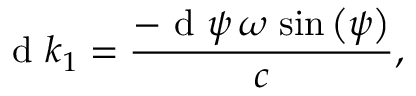Convert formula to latex. <formula><loc_0><loc_0><loc_500><loc_500>{ d } k _ { 1 } = \frac { - { d } \psi \, \omega \, \sin \left ( \psi \right ) } { c } ,</formula> 